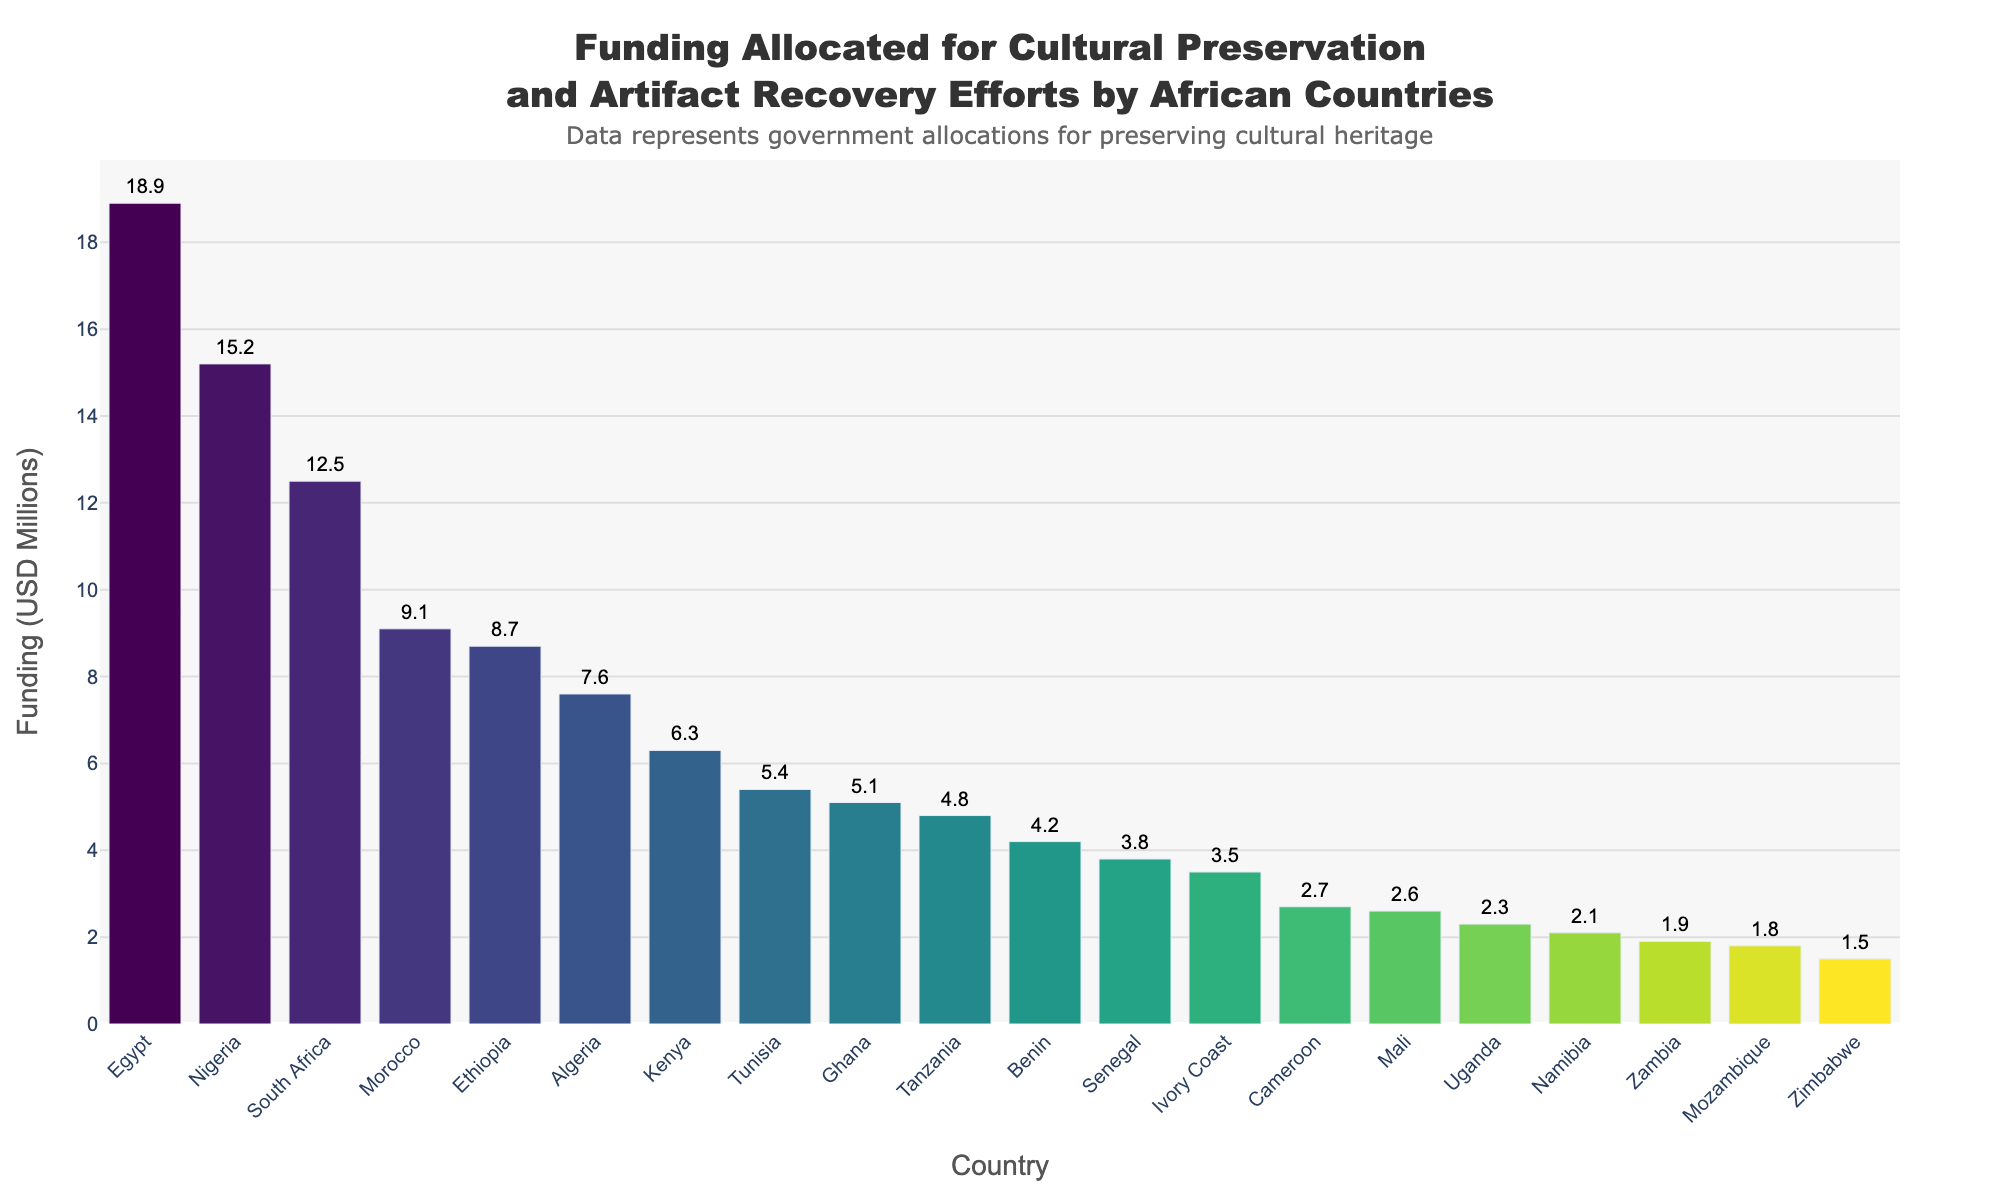Which country has allocated the highest funding for cultural preservation and artifact recovery efforts? To determine the country with the highest funding, look at the tallest bar in the chart. The country corresponding to this bar is Egypt.
Answer: Egypt Which country has allocated the lowest funding for cultural preservation and artifact recovery efforts? To find the country with the lowest funding, identify the shortest bar in the chart. The country corresponding to this bar is Zimbabwe.
Answer: Zimbabwe How much more funding has Nigeria allocated compared to Ghana? Observe the bar heights for Nigeria and Ghana. Nigeria has allocated $15.2 million, while Ghana has allocated $5.1 million. The difference is $15.2 - $5.1 = $10.1 million.
Answer: $10.1 million Which countries have allocated over $10 million for artifact recovery efforts? Look for the bars that exceed the $10 million mark on the Y-axis. The countries are Nigeria, South Africa, and Egypt.
Answer: Nigeria, South Africa, Egypt What is the average funding allocated by all the countries? Sum up the funding amounts of all countries and then divide by the number of countries. The total funding is $139.9 million, and there are 20 countries. So, the average is $139.9 / 20 = $7 million.
Answer: $7 million Which country has allocated exactly $8.7 million for cultural preservation? Identify the bar that corresponds to the $8.7 million mark on the Y-axis. The country is Ethiopia.
Answer: Ethiopia How much more funding combined do the top three countries allocate compared to the bottom three countries? Sum up the funding for the top three countries (Egypt, Nigeria, South Africa) and the bottom three countries (Zimbabwe, Zambia, Mozambique). Top three: $18.9 + $15.2 + $12.5 = $46.6 million. Bottom three: $1.5 + $1.9 + $1.8 = $5.2 million. The difference is $46.6 - $5.2 = $41.4 million.
Answer: $41.4 million Which countries have allocated between $5 million and $10 million? Look at bars that range between $5 million and $10 million on the Y-axis. These countries are Ethiopia, Nigeria, Tunisia, and Morocco.
Answer: Ethiopia, Nigeria, Tunisia, Morocco 